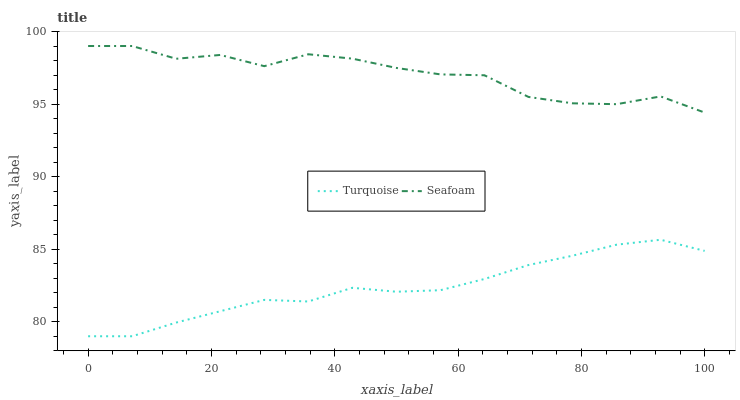Does Turquoise have the minimum area under the curve?
Answer yes or no. Yes. Does Seafoam have the maximum area under the curve?
Answer yes or no. Yes. Does Seafoam have the minimum area under the curve?
Answer yes or no. No. Is Turquoise the smoothest?
Answer yes or no. Yes. Is Seafoam the roughest?
Answer yes or no. Yes. Is Seafoam the smoothest?
Answer yes or no. No. Does Seafoam have the lowest value?
Answer yes or no. No. Does Seafoam have the highest value?
Answer yes or no. Yes. Is Turquoise less than Seafoam?
Answer yes or no. Yes. Is Seafoam greater than Turquoise?
Answer yes or no. Yes. Does Turquoise intersect Seafoam?
Answer yes or no. No. 